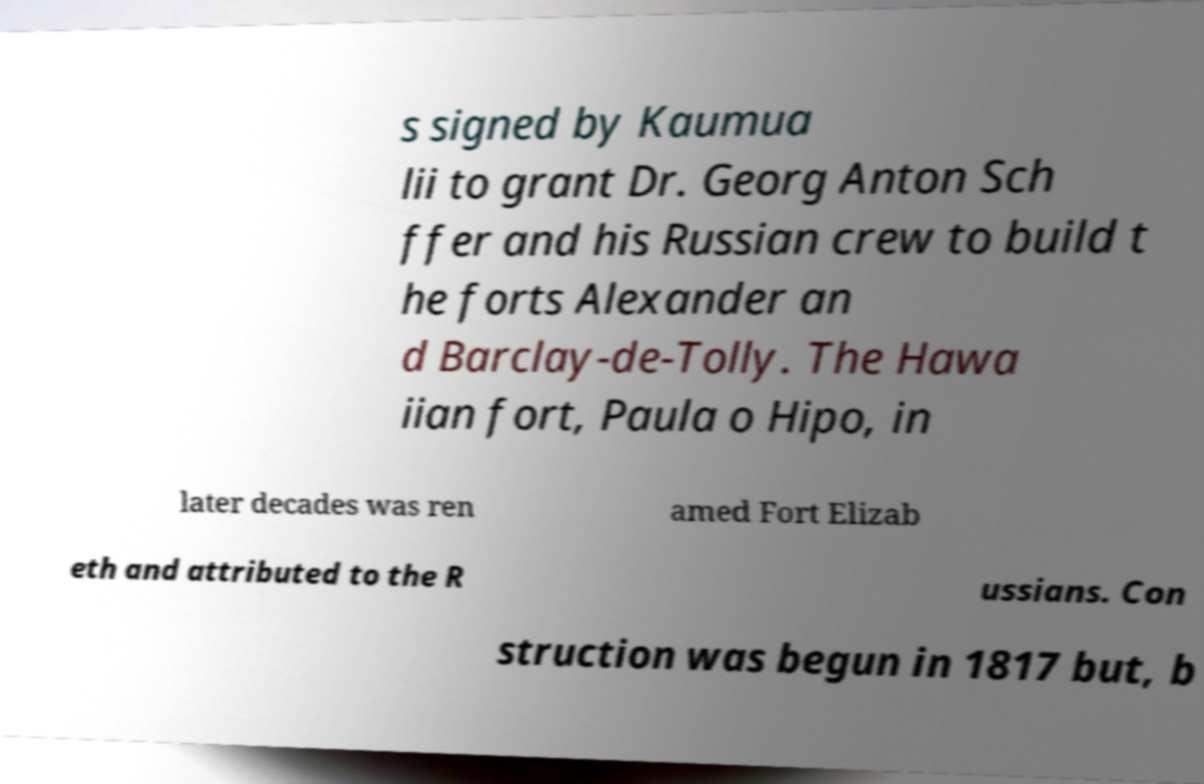Please read and relay the text visible in this image. What does it say? s signed by Kaumua lii to grant Dr. Georg Anton Sch ffer and his Russian crew to build t he forts Alexander an d Barclay-de-Tolly. The Hawa iian fort, Paula o Hipo, in later decades was ren amed Fort Elizab eth and attributed to the R ussians. Con struction was begun in 1817 but, b 